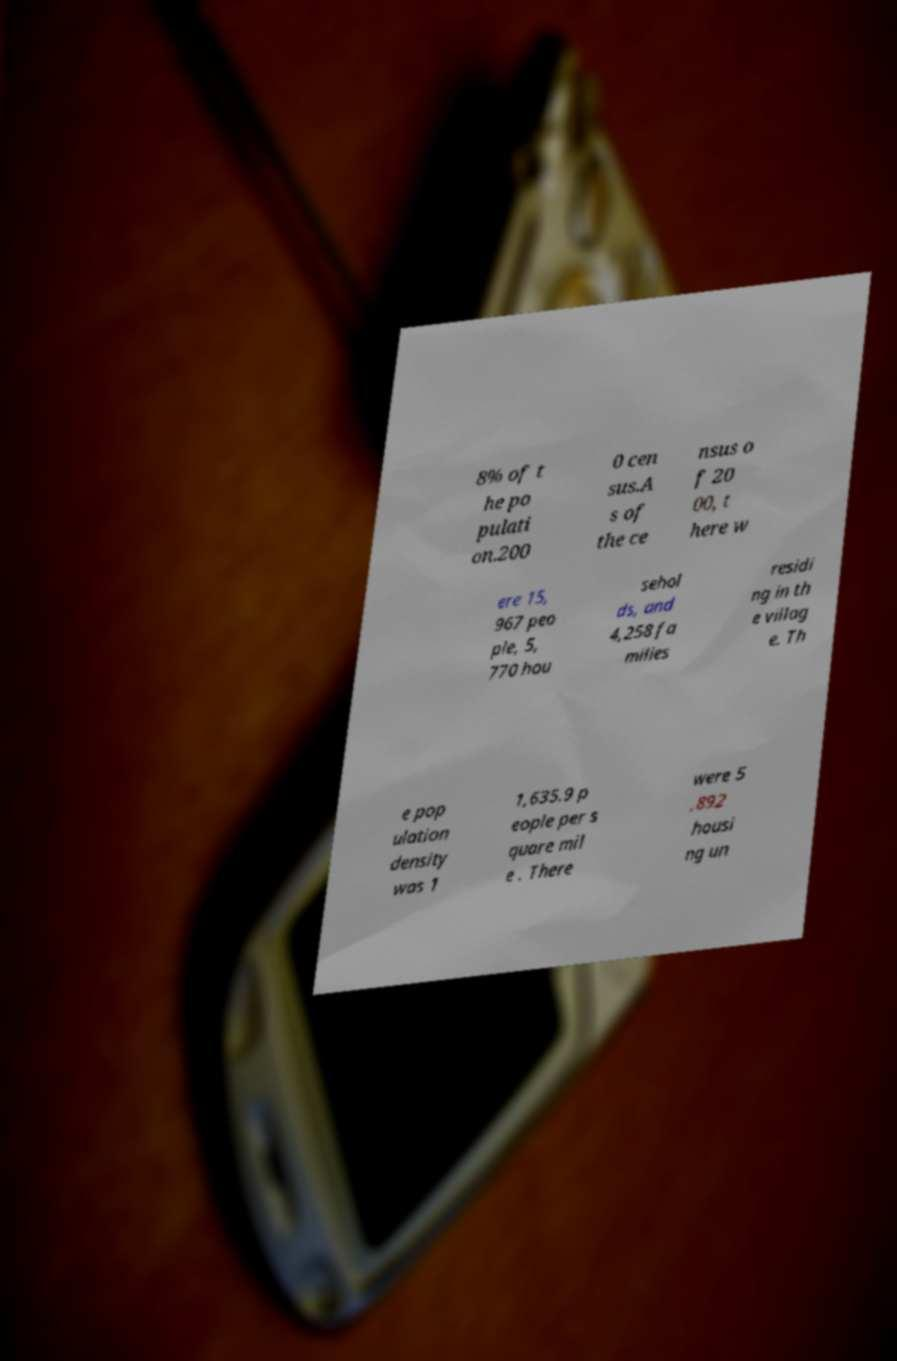Can you accurately transcribe the text from the provided image for me? 8% of t he po pulati on.200 0 cen sus.A s of the ce nsus o f 20 00, t here w ere 15, 967 peo ple, 5, 770 hou sehol ds, and 4,258 fa milies residi ng in th e villag e. Th e pop ulation density was 1 1,635.9 p eople per s quare mil e . There were 5 ,892 housi ng un 